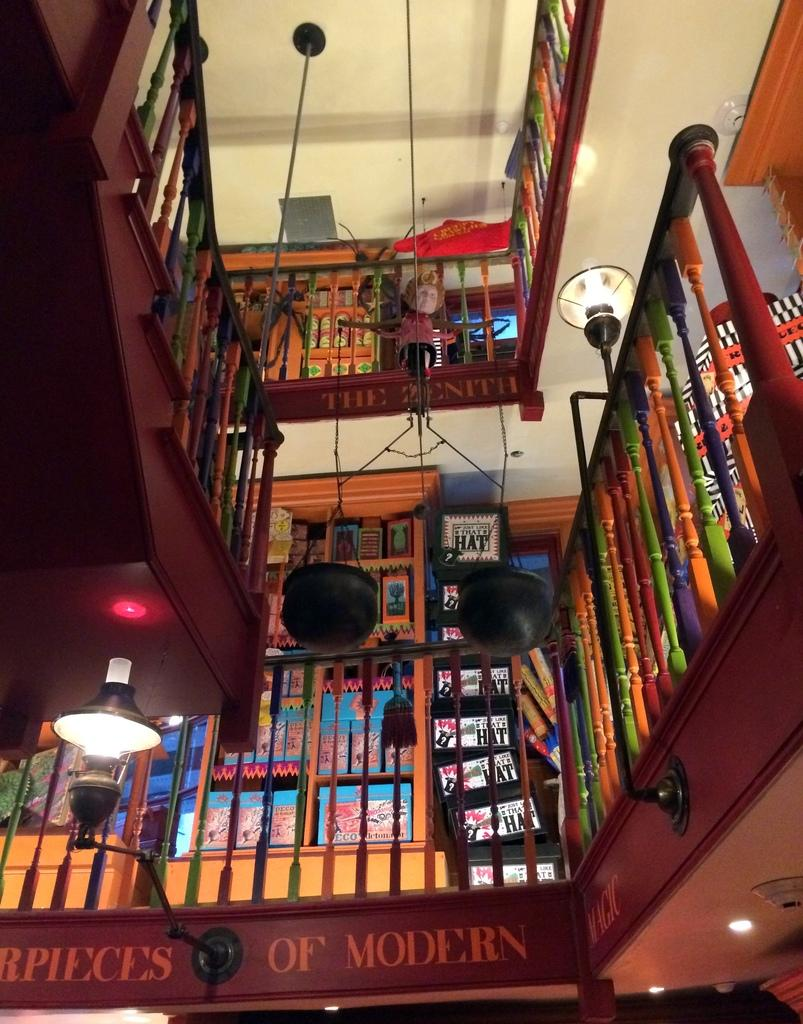<image>
Provide a brief description of the given image. The railings are multicolored in this library that displays masterpieces of modern magic. 